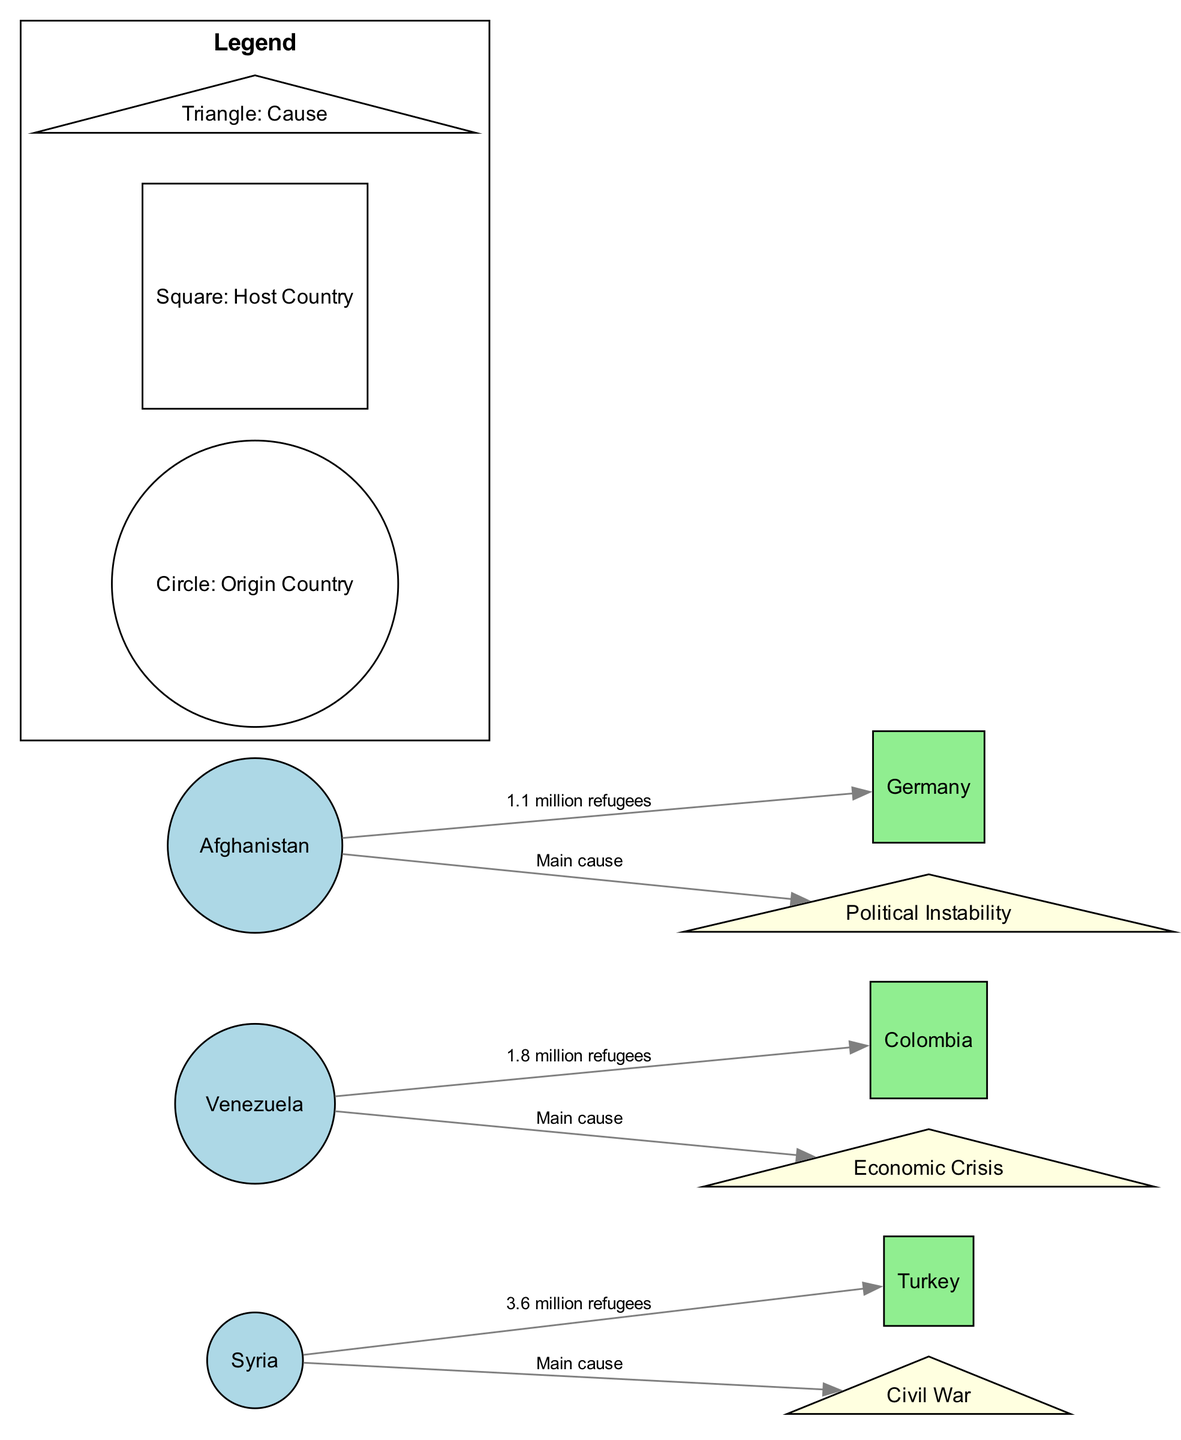What is the total number of refugees from Syria to Turkey? The diagram shows that there are 3.6 million refugees from Syria to Turkey, indicated by the direct edge from Syria to Turkey labeled "3.6 million refugees."
Answer: 3.6 million refugees How many countries act as host countries for refugees in the diagram? The diagram lists Turkey, Colombia, and Germany as host countries. There are three distinct squares representing these countries.
Answer: 3 What is the main cause of refugee movement from Venezuela? The diagram shows that the cause of refugee movement from Venezuela is "Economic Crisis," which is indicated by the edge connecting Venezuela to the triangle labeled "Economic Crisis."
Answer: Economic Crisis Which host country receives the fewest refugees? The relationships indicate that Colombia receives 1.8 million refugees from Venezuela, while Germany receives 1.1 million refugees from Afghanistan. Therefore, Germany receives the fewest refugees.
Answer: Germany How many distinct causes are indicated in the diagram? The diagram lists three distinct causes: Civil War, Economic Crisis, and Political Instability, represented by the three triangles in the diagram.
Answer: 3 What country has the highest number of refugees depicted in the diagram? The edge connecting Syria to Turkey shows 3.6 million refugees, which is the highest number in the diagram compared to the other edges.
Answer: Syria Which country has a refugee cause related to Political Instability? The diagram connects Afghanistan to Political Instability, indicating that it is the main cause of refugee movement from Afghanistan.
Answer: Afghanistan How many refugees are represented by the movements from Afghanistan? The diagram specifies that there are 1.1 million refugees moving from Afghanistan to Germany, shown by the labeled edge.
Answer: 1.1 million refugees Explain why there are fewer refugees from Afghanistan compared to Syria. The diagram details that Syria has a considerably larger number of refugees (3.6 million) due to the ongoing civil war, while Afghanistan only has 1.1 million refugees, linked to political instability. This suggests that the scale of conflict and crisis in Syria is more significant than in Afghanistan.
Answer: Ongoing civil war in Syria 